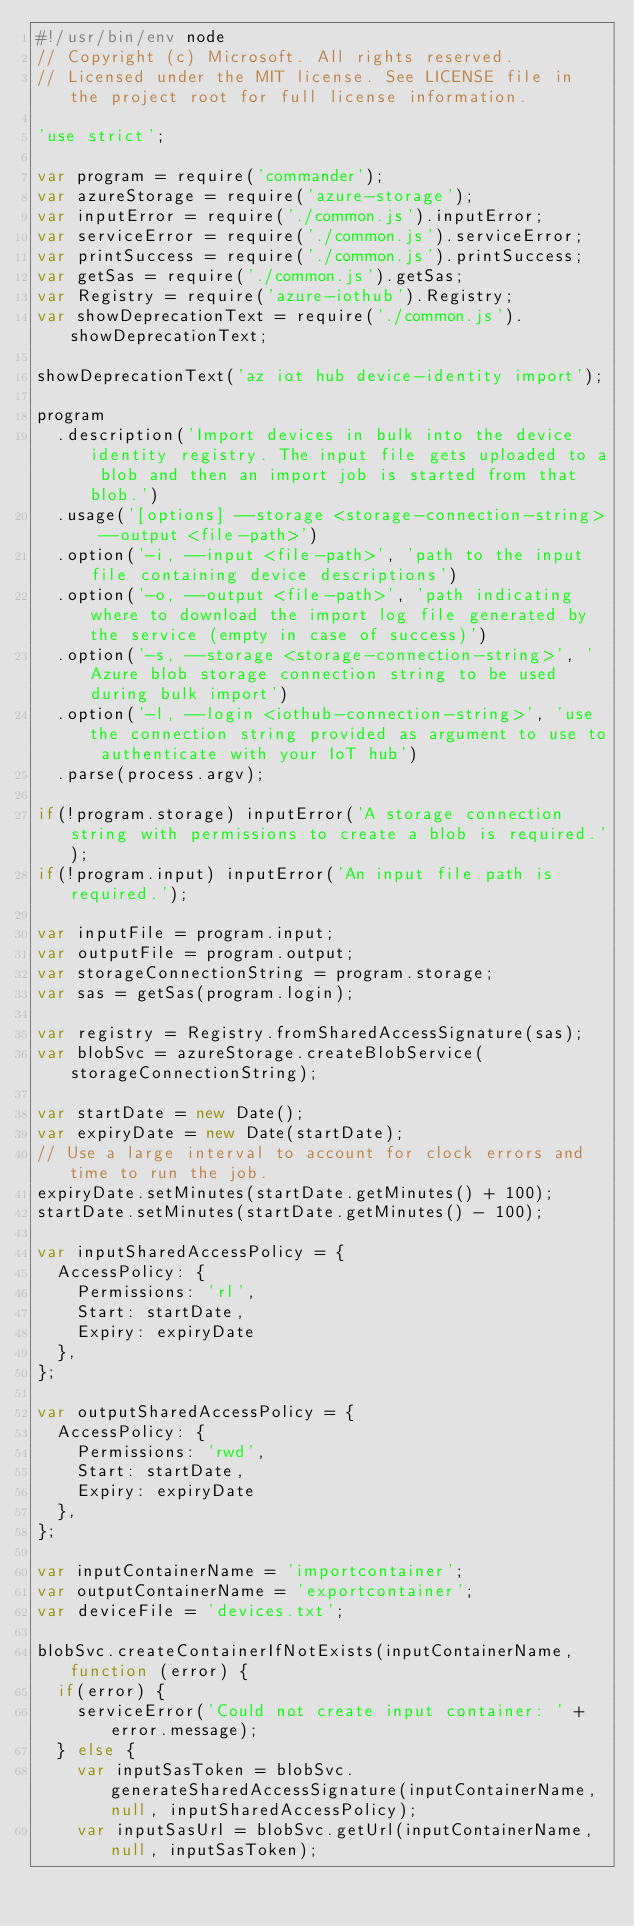Convert code to text. <code><loc_0><loc_0><loc_500><loc_500><_JavaScript_>#!/usr/bin/env node
// Copyright (c) Microsoft. All rights reserved.
// Licensed under the MIT license. See LICENSE file in the project root for full license information.

'use strict';

var program = require('commander');
var azureStorage = require('azure-storage');
var inputError = require('./common.js').inputError;
var serviceError = require('./common.js').serviceError;
var printSuccess = require('./common.js').printSuccess;
var getSas = require('./common.js').getSas;
var Registry = require('azure-iothub').Registry;
var showDeprecationText = require('./common.js').showDeprecationText;

showDeprecationText('az iot hub device-identity import');

program
  .description('Import devices in bulk into the device identity registry. The input file gets uploaded to a blob and then an import job is started from that blob.')
  .usage('[options] --storage <storage-connection-string> --output <file-path>')
  .option('-i, --input <file-path>', 'path to the input file containing device descriptions')
  .option('-o, --output <file-path>', 'path indicating where to download the import log file generated by the service (empty in case of success)')
  .option('-s, --storage <storage-connection-string>', 'Azure blob storage connection string to be used during bulk import')
  .option('-l, --login <iothub-connection-string>', 'use the connection string provided as argument to use to authenticate with your IoT hub')
  .parse(process.argv);

if(!program.storage) inputError('A storage connection string with permissions to create a blob is required.');
if(!program.input) inputError('An input file path is required.');

var inputFile = program.input;
var outputFile = program.output;
var storageConnectionString = program.storage;
var sas = getSas(program.login);

var registry = Registry.fromSharedAccessSignature(sas);
var blobSvc = azureStorage.createBlobService(storageConnectionString);

var startDate = new Date();
var expiryDate = new Date(startDate);
// Use a large interval to account for clock errors and time to run the job.
expiryDate.setMinutes(startDate.getMinutes() + 100);
startDate.setMinutes(startDate.getMinutes() - 100);

var inputSharedAccessPolicy = {
  AccessPolicy: {
    Permissions: 'rl',
    Start: startDate,
    Expiry: expiryDate
  },
};

var outputSharedAccessPolicy = {
  AccessPolicy: {
    Permissions: 'rwd',
    Start: startDate,
    Expiry: expiryDate
  },
};

var inputContainerName = 'importcontainer';
var outputContainerName = 'exportcontainer';
var deviceFile = 'devices.txt';

blobSvc.createContainerIfNotExists(inputContainerName, function (error) {
  if(error) {
    serviceError('Could not create input container: ' + error.message);
  } else {
    var inputSasToken = blobSvc.generateSharedAccessSignature(inputContainerName, null, inputSharedAccessPolicy);
    var inputSasUrl = blobSvc.getUrl(inputContainerName, null, inputSasToken);</code> 